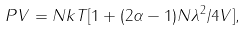Convert formula to latex. <formula><loc_0><loc_0><loc_500><loc_500>P V = N k T [ 1 + ( 2 \alpha - 1 ) N \lambda ^ { 2 } / 4 V ] ,</formula> 